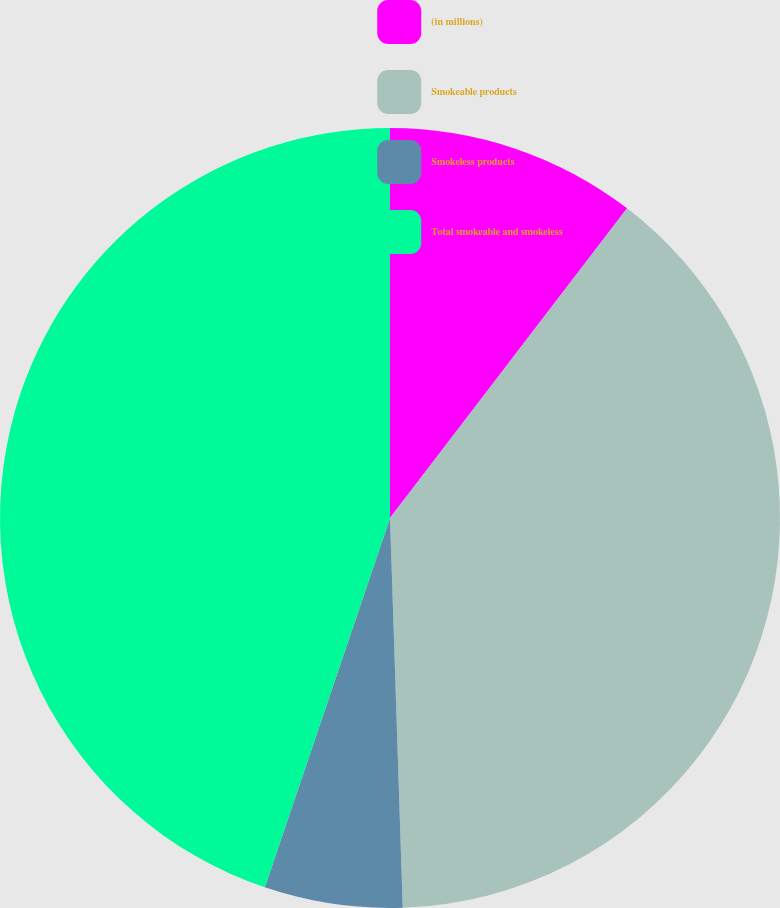Convert chart to OTSL. <chart><loc_0><loc_0><loc_500><loc_500><pie_chart><fcel>(in millions)<fcel>Smokeable products<fcel>Smokeless products<fcel>Total smokeable and smokeless<nl><fcel>10.4%<fcel>39.08%<fcel>5.72%<fcel>44.8%<nl></chart> 